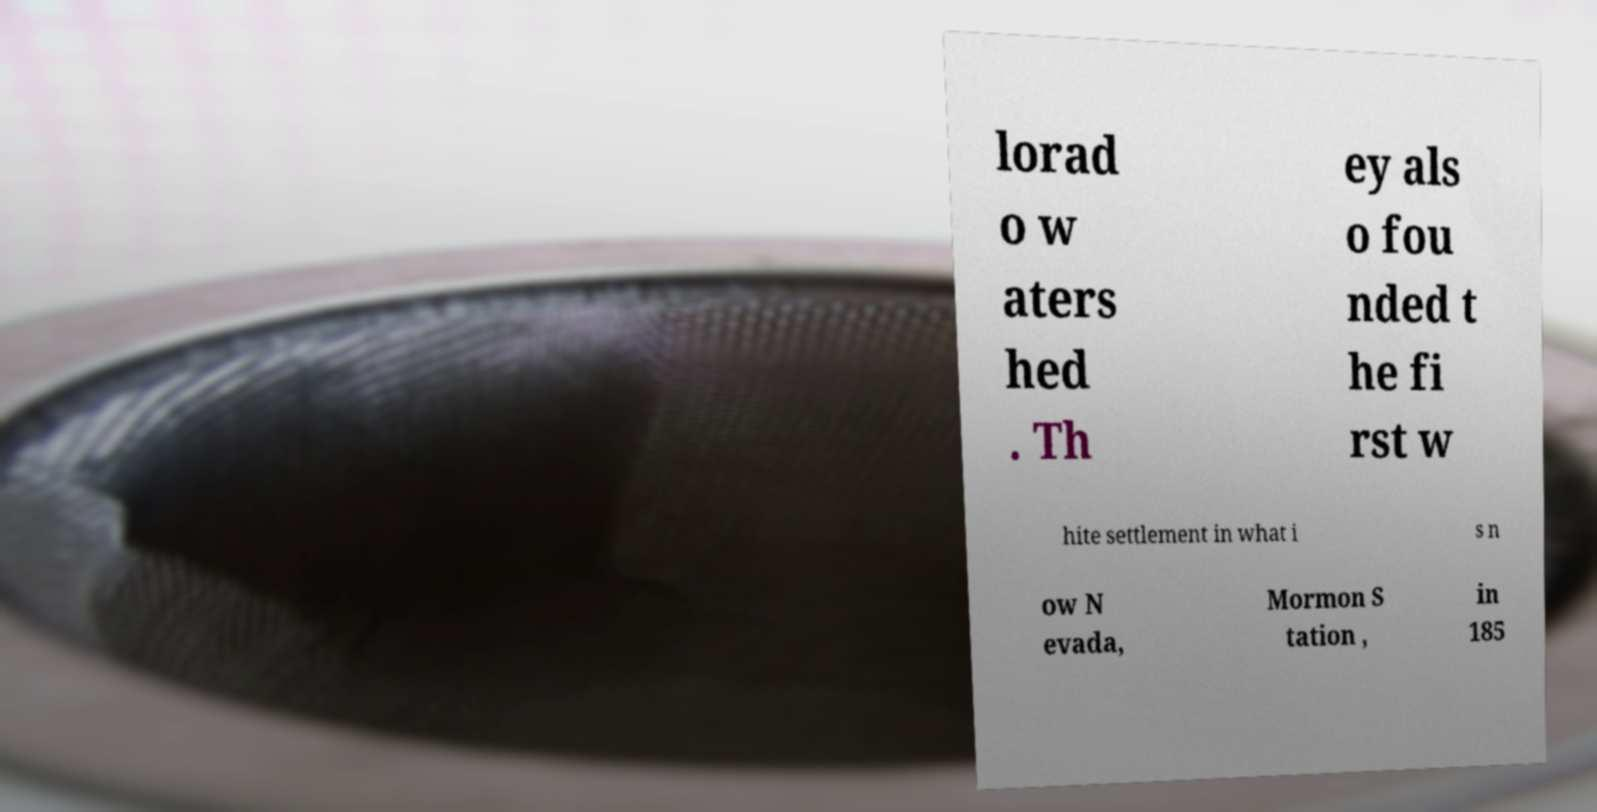Can you read and provide the text displayed in the image?This photo seems to have some interesting text. Can you extract and type it out for me? lorad o w aters hed . Th ey als o fou nded t he fi rst w hite settlement in what i s n ow N evada, Mormon S tation , in 185 